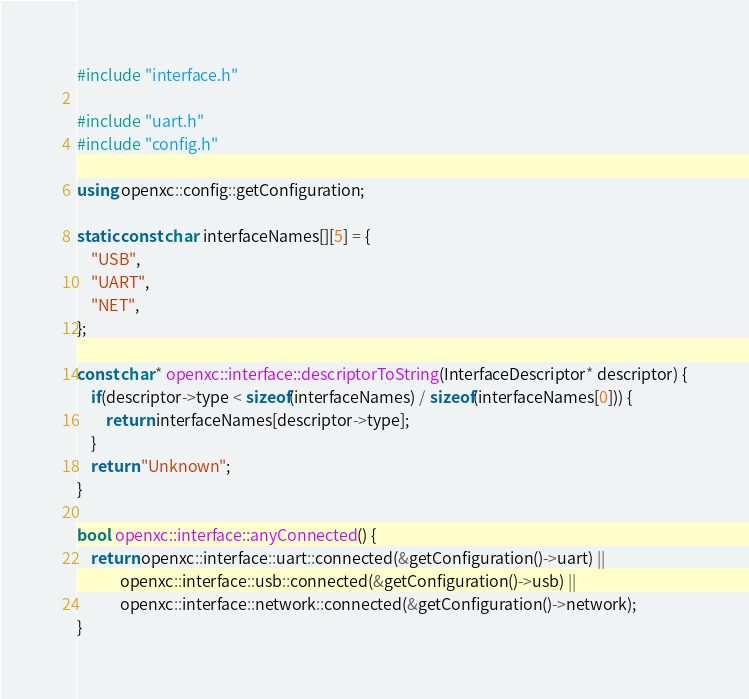Convert code to text. <code><loc_0><loc_0><loc_500><loc_500><_C++_>#include "interface.h"

#include "uart.h"
#include "config.h"

using openxc::config::getConfiguration;

static const char interfaceNames[][5] = {
    "USB",
    "UART",
    "NET",
};

const char* openxc::interface::descriptorToString(InterfaceDescriptor* descriptor) {
    if(descriptor->type < sizeof(interfaceNames) / sizeof(interfaceNames[0])) {
        return interfaceNames[descriptor->type];
    }
    return "Unknown";
}

bool openxc::interface::anyConnected() {
    return openxc::interface::uart::connected(&getConfiguration()->uart) ||
            openxc::interface::usb::connected(&getConfiguration()->usb) ||
            openxc::interface::network::connected(&getConfiguration()->network);
}
</code> 